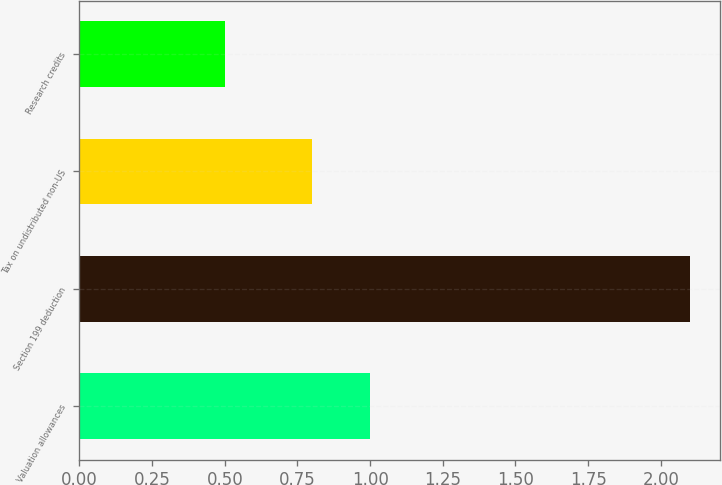Convert chart to OTSL. <chart><loc_0><loc_0><loc_500><loc_500><bar_chart><fcel>Valuation allowances<fcel>Section 199 deduction<fcel>Tax on undistributed non-US<fcel>Research credits<nl><fcel>1<fcel>2.1<fcel>0.8<fcel>0.5<nl></chart> 